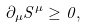<formula> <loc_0><loc_0><loc_500><loc_500>\partial _ { \mu } S ^ { \mu } \geq 0 ,</formula> 